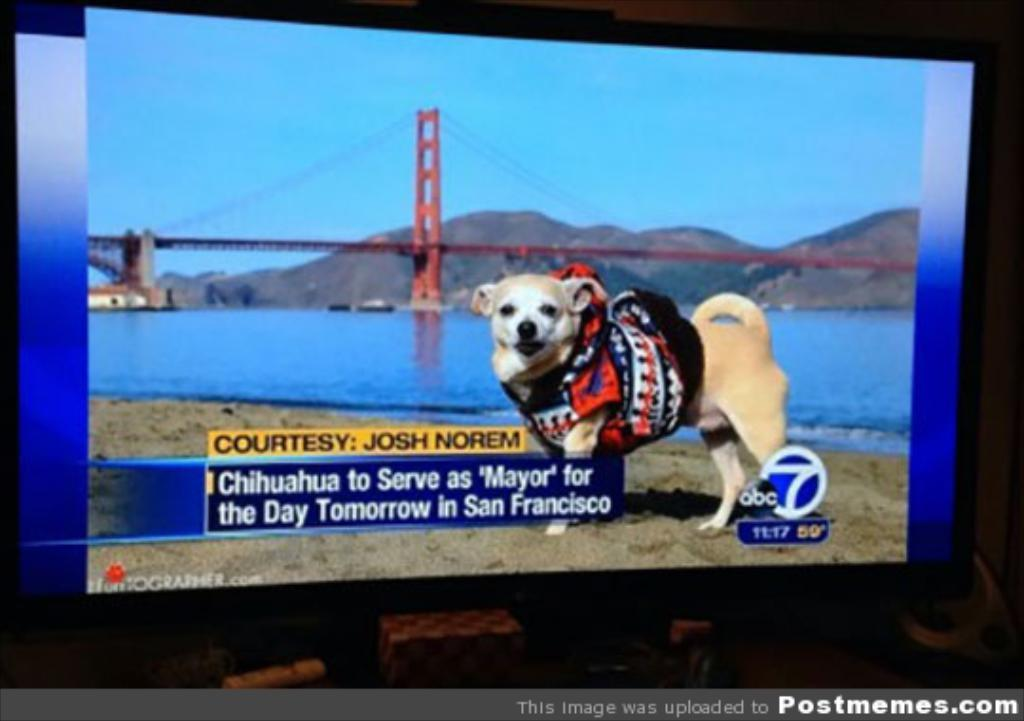What is the main object in the image? There is a display screen in the image. What is shown on the display screen? The display screen shows a picture of a dog standing on the ground, a river, a bridge, hills, and the sky. Can you describe the pictures shown on the display screen? The display screen shows a picture of a dog standing on the ground, a river, a bridge, hills, and the sky. What book is the dog reading in the image? There is no dog reading a book, or any book present in the image. 